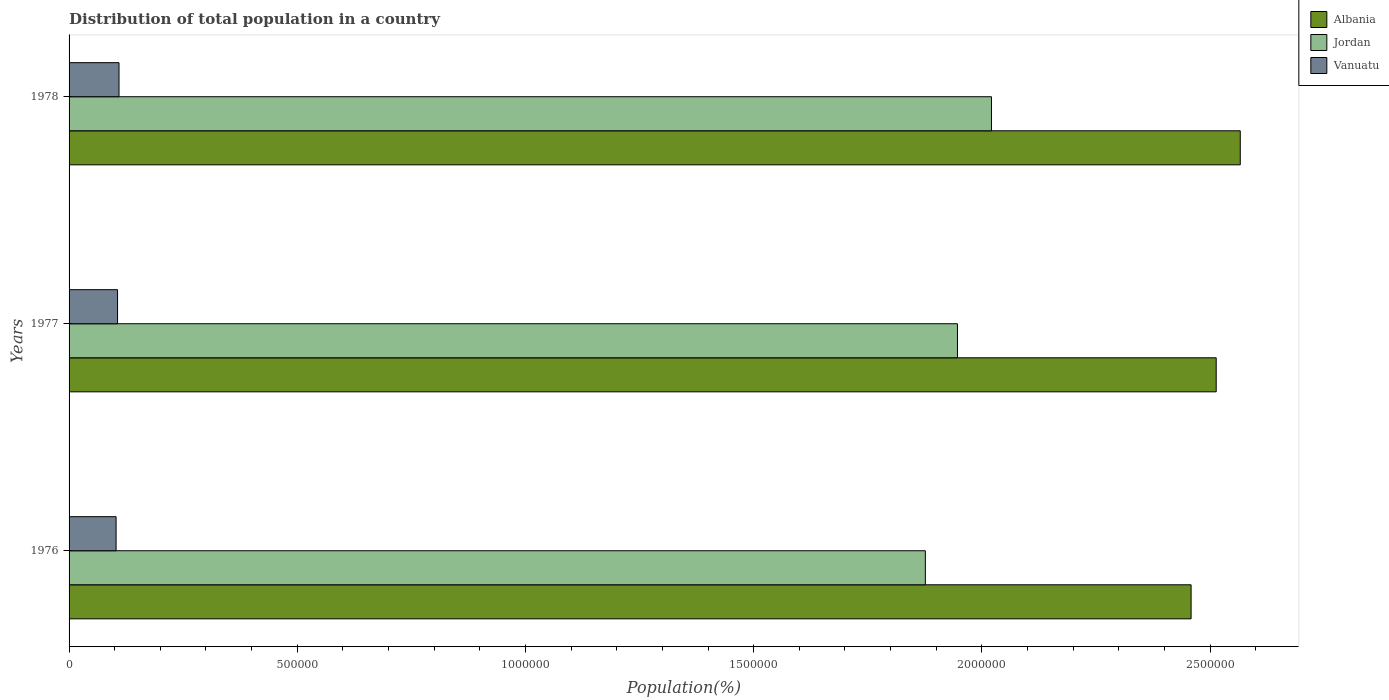How many groups of bars are there?
Your answer should be very brief. 3. Are the number of bars on each tick of the Y-axis equal?
Provide a short and direct response. Yes. How many bars are there on the 2nd tick from the bottom?
Your response must be concise. 3. What is the population of in Vanuatu in 1976?
Give a very brief answer. 1.03e+05. Across all years, what is the maximum population of in Albania?
Your answer should be very brief. 2.57e+06. Across all years, what is the minimum population of in Jordan?
Your answer should be very brief. 1.88e+06. In which year was the population of in Vanuatu maximum?
Your answer should be compact. 1978. In which year was the population of in Jordan minimum?
Provide a succinct answer. 1976. What is the total population of in Jordan in the graph?
Keep it short and to the point. 5.84e+06. What is the difference between the population of in Vanuatu in 1976 and that in 1977?
Your response must be concise. -3199. What is the difference between the population of in Jordan in 1977 and the population of in Albania in 1976?
Ensure brevity in your answer.  -5.12e+05. What is the average population of in Jordan per year?
Keep it short and to the point. 1.95e+06. In the year 1976, what is the difference between the population of in Jordan and population of in Vanuatu?
Provide a short and direct response. 1.77e+06. What is the ratio of the population of in Jordan in 1976 to that in 1978?
Offer a terse response. 0.93. Is the population of in Albania in 1976 less than that in 1978?
Offer a very short reply. Yes. Is the difference between the population of in Jordan in 1977 and 1978 greater than the difference between the population of in Vanuatu in 1977 and 1978?
Keep it short and to the point. No. What is the difference between the highest and the second highest population of in Jordan?
Provide a short and direct response. 7.45e+04. What is the difference between the highest and the lowest population of in Albania?
Make the answer very short. 1.08e+05. In how many years, is the population of in Jordan greater than the average population of in Jordan taken over all years?
Ensure brevity in your answer.  1. Is the sum of the population of in Jordan in 1976 and 1978 greater than the maximum population of in Albania across all years?
Offer a very short reply. Yes. What does the 3rd bar from the top in 1978 represents?
Your response must be concise. Albania. What does the 1st bar from the bottom in 1978 represents?
Your response must be concise. Albania. Is it the case that in every year, the sum of the population of in Albania and population of in Vanuatu is greater than the population of in Jordan?
Ensure brevity in your answer.  Yes. How many years are there in the graph?
Your answer should be very brief. 3. What is the difference between two consecutive major ticks on the X-axis?
Offer a terse response. 5.00e+05. How many legend labels are there?
Provide a succinct answer. 3. How are the legend labels stacked?
Provide a succinct answer. Vertical. What is the title of the graph?
Make the answer very short. Distribution of total population in a country. What is the label or title of the X-axis?
Keep it short and to the point. Population(%). What is the Population(%) of Albania in 1976?
Offer a terse response. 2.46e+06. What is the Population(%) in Jordan in 1976?
Your answer should be very brief. 1.88e+06. What is the Population(%) in Vanuatu in 1976?
Provide a succinct answer. 1.03e+05. What is the Population(%) in Albania in 1977?
Provide a succinct answer. 2.51e+06. What is the Population(%) of Jordan in 1977?
Provide a succinct answer. 1.95e+06. What is the Population(%) of Vanuatu in 1977?
Your answer should be very brief. 1.06e+05. What is the Population(%) of Albania in 1978?
Offer a terse response. 2.57e+06. What is the Population(%) in Jordan in 1978?
Make the answer very short. 2.02e+06. What is the Population(%) of Vanuatu in 1978?
Your answer should be compact. 1.09e+05. Across all years, what is the maximum Population(%) in Albania?
Offer a terse response. 2.57e+06. Across all years, what is the maximum Population(%) of Jordan?
Your answer should be compact. 2.02e+06. Across all years, what is the maximum Population(%) of Vanuatu?
Give a very brief answer. 1.09e+05. Across all years, what is the minimum Population(%) of Albania?
Provide a short and direct response. 2.46e+06. Across all years, what is the minimum Population(%) of Jordan?
Your response must be concise. 1.88e+06. Across all years, what is the minimum Population(%) in Vanuatu?
Your answer should be compact. 1.03e+05. What is the total Population(%) in Albania in the graph?
Offer a very short reply. 7.54e+06. What is the total Population(%) in Jordan in the graph?
Give a very brief answer. 5.84e+06. What is the total Population(%) of Vanuatu in the graph?
Give a very brief answer. 3.19e+05. What is the difference between the Population(%) in Albania in 1976 and that in 1977?
Your response must be concise. -5.50e+04. What is the difference between the Population(%) of Jordan in 1976 and that in 1977?
Offer a terse response. -7.04e+04. What is the difference between the Population(%) of Vanuatu in 1976 and that in 1977?
Your answer should be very brief. -3199. What is the difference between the Population(%) in Albania in 1976 and that in 1978?
Offer a very short reply. -1.08e+05. What is the difference between the Population(%) of Jordan in 1976 and that in 1978?
Provide a succinct answer. -1.45e+05. What is the difference between the Population(%) of Vanuatu in 1976 and that in 1978?
Your answer should be compact. -6405. What is the difference between the Population(%) of Albania in 1977 and that in 1978?
Ensure brevity in your answer.  -5.27e+04. What is the difference between the Population(%) of Jordan in 1977 and that in 1978?
Keep it short and to the point. -7.45e+04. What is the difference between the Population(%) of Vanuatu in 1977 and that in 1978?
Your answer should be compact. -3206. What is the difference between the Population(%) in Albania in 1976 and the Population(%) in Jordan in 1977?
Ensure brevity in your answer.  5.12e+05. What is the difference between the Population(%) of Albania in 1976 and the Population(%) of Vanuatu in 1977?
Your answer should be compact. 2.35e+06. What is the difference between the Population(%) of Jordan in 1976 and the Population(%) of Vanuatu in 1977?
Provide a short and direct response. 1.77e+06. What is the difference between the Population(%) in Albania in 1976 and the Population(%) in Jordan in 1978?
Your answer should be very brief. 4.37e+05. What is the difference between the Population(%) of Albania in 1976 and the Population(%) of Vanuatu in 1978?
Your answer should be compact. 2.35e+06. What is the difference between the Population(%) of Jordan in 1976 and the Population(%) of Vanuatu in 1978?
Offer a terse response. 1.77e+06. What is the difference between the Population(%) of Albania in 1977 and the Population(%) of Jordan in 1978?
Provide a succinct answer. 4.92e+05. What is the difference between the Population(%) of Albania in 1977 and the Population(%) of Vanuatu in 1978?
Your answer should be very brief. 2.40e+06. What is the difference between the Population(%) in Jordan in 1977 and the Population(%) in Vanuatu in 1978?
Provide a short and direct response. 1.84e+06. What is the average Population(%) of Albania per year?
Provide a short and direct response. 2.51e+06. What is the average Population(%) in Jordan per year?
Keep it short and to the point. 1.95e+06. What is the average Population(%) in Vanuatu per year?
Keep it short and to the point. 1.06e+05. In the year 1976, what is the difference between the Population(%) in Albania and Population(%) in Jordan?
Keep it short and to the point. 5.82e+05. In the year 1976, what is the difference between the Population(%) of Albania and Population(%) of Vanuatu?
Keep it short and to the point. 2.36e+06. In the year 1976, what is the difference between the Population(%) of Jordan and Population(%) of Vanuatu?
Ensure brevity in your answer.  1.77e+06. In the year 1977, what is the difference between the Population(%) in Albania and Population(%) in Jordan?
Your response must be concise. 5.67e+05. In the year 1977, what is the difference between the Population(%) in Albania and Population(%) in Vanuatu?
Make the answer very short. 2.41e+06. In the year 1977, what is the difference between the Population(%) of Jordan and Population(%) of Vanuatu?
Make the answer very short. 1.84e+06. In the year 1978, what is the difference between the Population(%) in Albania and Population(%) in Jordan?
Ensure brevity in your answer.  5.45e+05. In the year 1978, what is the difference between the Population(%) of Albania and Population(%) of Vanuatu?
Your response must be concise. 2.46e+06. In the year 1978, what is the difference between the Population(%) in Jordan and Population(%) in Vanuatu?
Make the answer very short. 1.91e+06. What is the ratio of the Population(%) of Albania in 1976 to that in 1977?
Make the answer very short. 0.98. What is the ratio of the Population(%) in Jordan in 1976 to that in 1977?
Your answer should be very brief. 0.96. What is the ratio of the Population(%) in Vanuatu in 1976 to that in 1977?
Offer a very short reply. 0.97. What is the ratio of the Population(%) of Albania in 1976 to that in 1978?
Offer a terse response. 0.96. What is the ratio of the Population(%) in Jordan in 1976 to that in 1978?
Provide a succinct answer. 0.93. What is the ratio of the Population(%) of Vanuatu in 1976 to that in 1978?
Make the answer very short. 0.94. What is the ratio of the Population(%) of Albania in 1977 to that in 1978?
Provide a short and direct response. 0.98. What is the ratio of the Population(%) of Jordan in 1977 to that in 1978?
Your answer should be compact. 0.96. What is the ratio of the Population(%) of Vanuatu in 1977 to that in 1978?
Ensure brevity in your answer.  0.97. What is the difference between the highest and the second highest Population(%) of Albania?
Give a very brief answer. 5.27e+04. What is the difference between the highest and the second highest Population(%) of Jordan?
Ensure brevity in your answer.  7.45e+04. What is the difference between the highest and the second highest Population(%) in Vanuatu?
Provide a succinct answer. 3206. What is the difference between the highest and the lowest Population(%) in Albania?
Provide a succinct answer. 1.08e+05. What is the difference between the highest and the lowest Population(%) of Jordan?
Your response must be concise. 1.45e+05. What is the difference between the highest and the lowest Population(%) in Vanuatu?
Your response must be concise. 6405. 